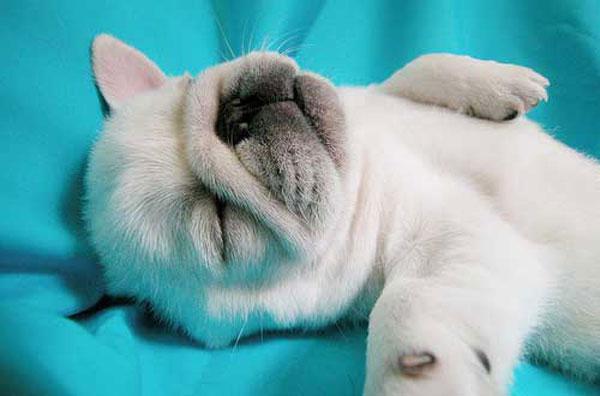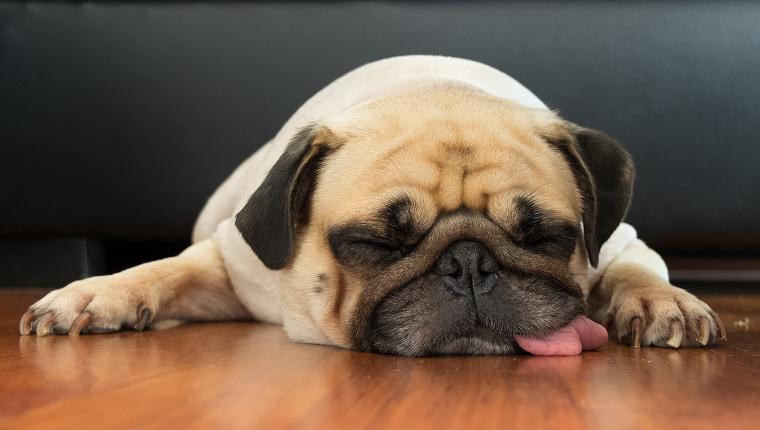The first image is the image on the left, the second image is the image on the right. For the images shown, is this caption "One white dog and one brown dog are sleeping." true? Answer yes or no. Yes. 